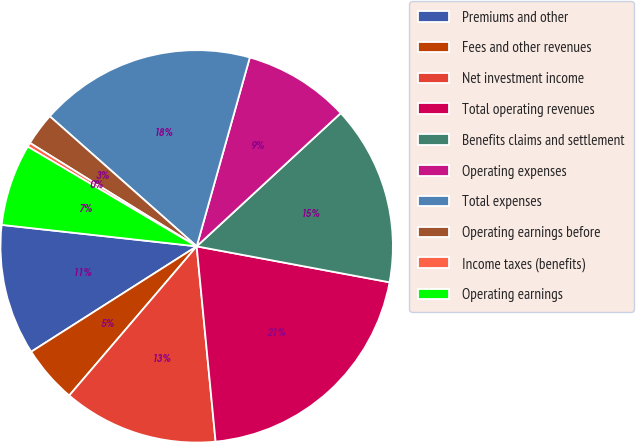Convert chart. <chart><loc_0><loc_0><loc_500><loc_500><pie_chart><fcel>Premiums and other<fcel>Fees and other revenues<fcel>Net investment income<fcel>Total operating revenues<fcel>Benefits claims and settlement<fcel>Operating expenses<fcel>Total expenses<fcel>Operating earnings before<fcel>Income taxes (benefits)<fcel>Operating earnings<nl><fcel>10.77%<fcel>4.72%<fcel>12.79%<fcel>20.53%<fcel>14.81%<fcel>8.76%<fcel>17.83%<fcel>2.7%<fcel>0.35%<fcel>6.74%<nl></chart> 